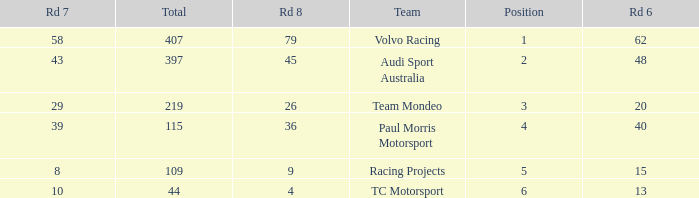What is the average value for Rd 8 in a position less than 2 for Audi Sport Australia? None. 